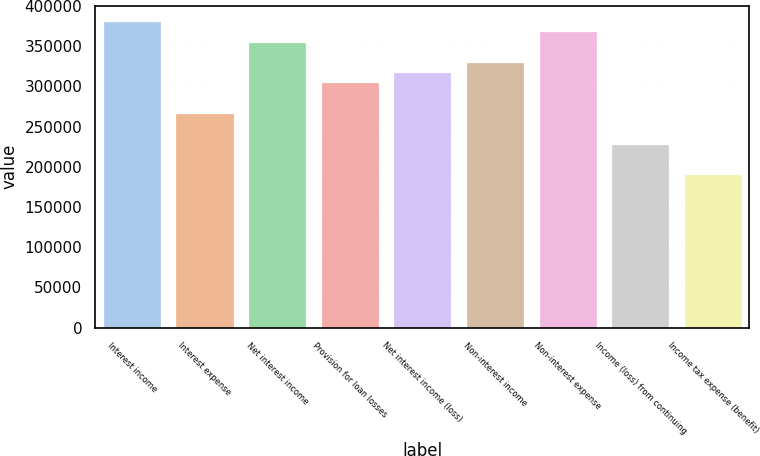Convert chart. <chart><loc_0><loc_0><loc_500><loc_500><bar_chart><fcel>Interest income<fcel>Interest expense<fcel>Net interest income<fcel>Provision for loan losses<fcel>Net interest income (loss)<fcel>Non-interest income<fcel>Non-interest expense<fcel>Income (loss) from continuing<fcel>Income tax expense (benefit)<nl><fcel>381150<fcel>266805<fcel>355740<fcel>304920<fcel>317625<fcel>330330<fcel>368445<fcel>228690<fcel>190575<nl></chart> 